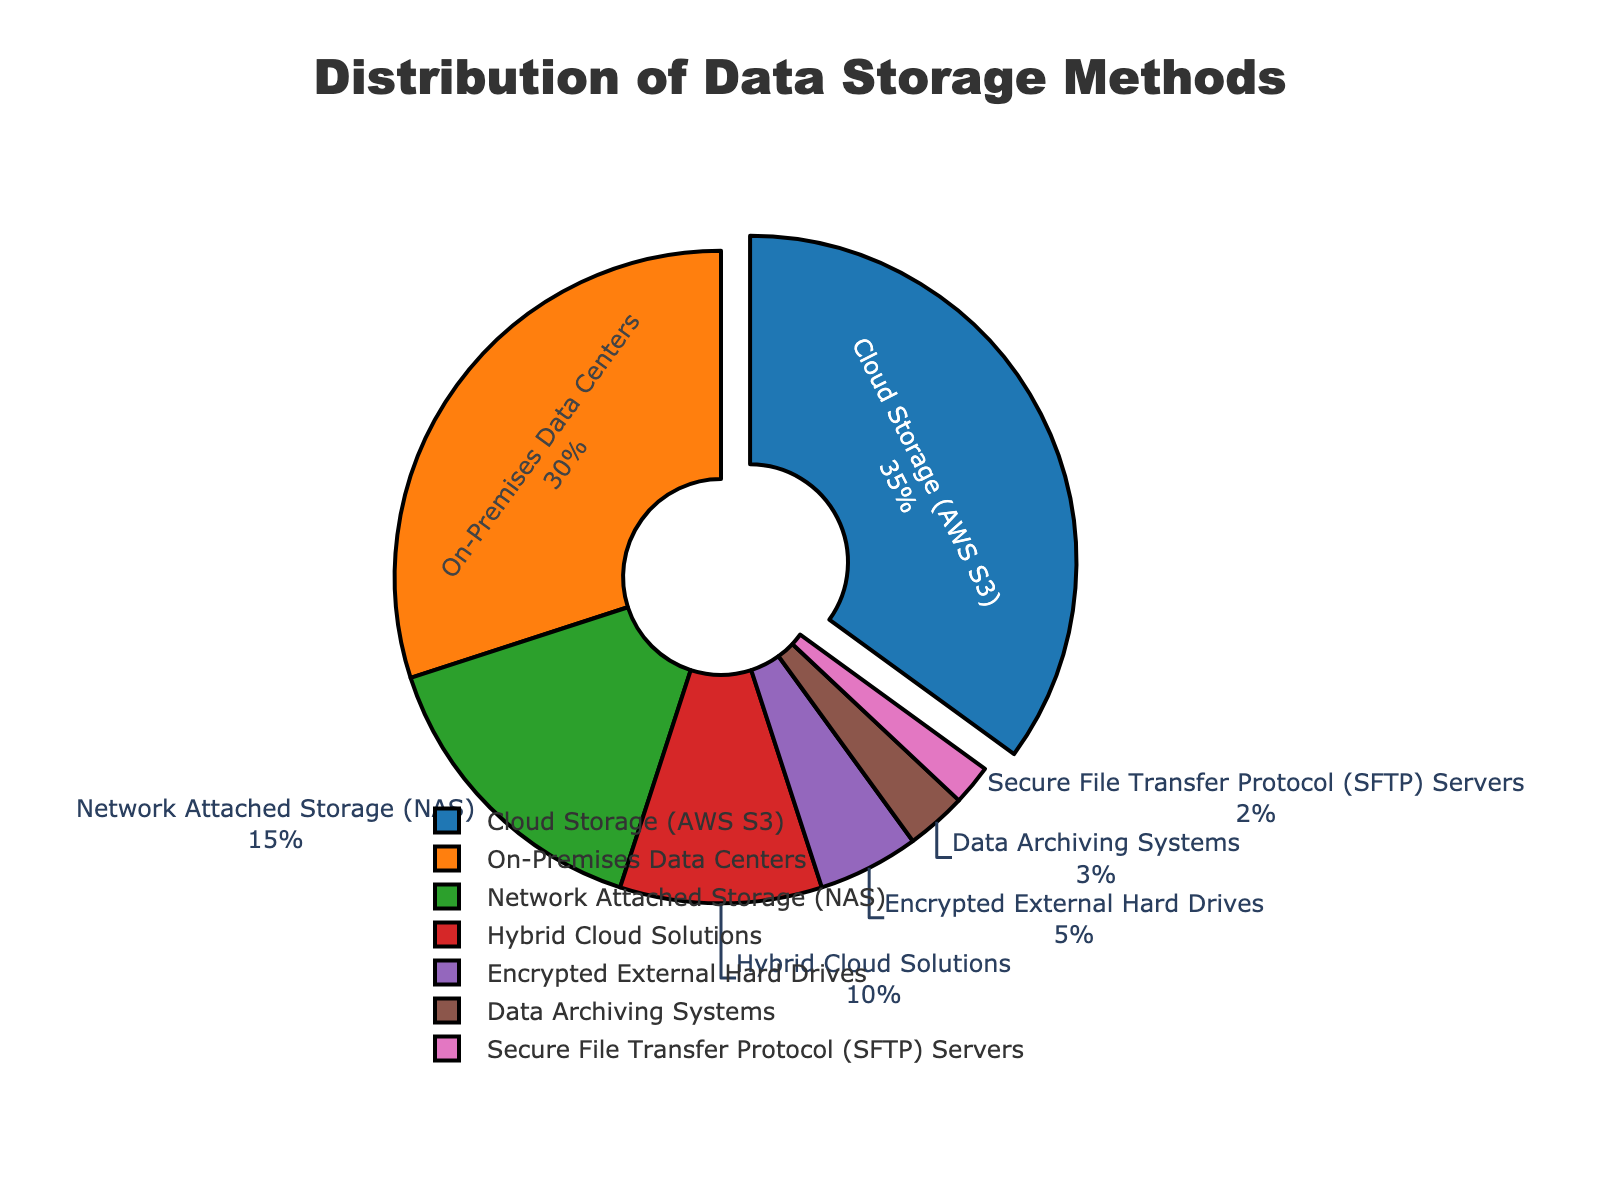Which storage method has the highest percentage? Cloud Storage (AWS S3) has the highest percentage because it occupies the largest portion of the pie chart and has a value of 35%.
Answer: Cloud Storage (AWS S3) How much greater is the percentage of Cloud Storage (AWS S3) compared to Encrypted External Hard Drives? Cloud Storage (AWS S3) has 35% and Encrypted External Hard Drives have 5%. The difference is 35% - 5% = 30%.
Answer: 30% What is the combined percentage of On-Premises Data Centers and Network Attached Storage (NAS)? On-Premises Data Centers have 30% and Network Attached Storage (NAS) has 15%. Adding them together gives 30% + 15% = 45%.
Answer: 45% Which two storage methods together make up less than 10% of the total storage methods? Data Archiving Systems (3%) and Secure File Transfer Protocol (SFTP) Servers (2%) together make 3% + 2% = 5%, which is less than 10%.
Answer: Data Archiving Systems and Secure File Transfer Protocol (SFTP) Servers What is the least used storage method? The least used storage method is Secure File Transfer Protocol (SFTP) Servers with 2%.
Answer: Secure File Transfer Protocol (SFTP) Servers Is the sum of the percentages of Hybrid Cloud Solutions and Data Archiving Systems more or less than Network Attached Storage (NAS)? Hybrid Cloud Solutions have 10% and Data Archiving Systems have 3%. Together they sum to 10% + 3% = 13%. Network Attached Storage (NAS) has 15%, so 13% is less than 15%.
Answer: Less If the percentage of Network Attached Storage (NAS) doubled, what would its new percentage be? Would it become the highest among the storage methods? Doubling the percentage of Network Attached Storage (NAS), we get 15% * 2 = 30%. Cloud Storage (AWS S3) would still be higher at 35%, so it would not become the highest.
Answer: 30%, No By how much does the percentage of On-Premises Data Centers exceed that of Hybrid Cloud Solutions? On-Premises Data Centers have 30% and Hybrid Cloud Solutions have 10%, so the difference is 30% - 10% = 20%.
Answer: 20% What is the combined percentage of all storage methods that are used less than 10% each? Hybrid Cloud Solutions (10%), Encrypted External Hard Drives (5%), Data Archiving Systems (3%), and Secure File Transfer Protocol (SFTP) Servers (2%) each used less than 10%. Adding them together gives 10% + 5% + 3% + 2% = 20%.
Answer: 20% Which color corresponds to the most used storage method? The most used storage method is Cloud Storage (AWS S3) which is represented by the blue section of the pie chart.
Answer: Blue 